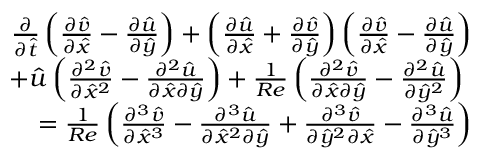<formula> <loc_0><loc_0><loc_500><loc_500>\begin{array} { r } { \frac { \partial } { \partial \hat { t } } \left ( { \frac { \partial \hat { v } } { \partial \hat { x } } - \frac { \partial \hat { u } } { \partial \hat { y } } } \right ) + \left ( { \frac { \partial \hat { u } } { \partial \hat { x } } + \frac { \partial \hat { v } } { \partial \hat { y } } } \right ) \left ( { \frac { \partial \hat { v } } { \partial \hat { x } } - \frac { \partial \hat { u } } { \partial \hat { y } } } \right ) } \\ { + \hat { u } \left ( { \frac { \partial ^ { 2 } \hat { v } } { \partial { \hat { x } } ^ { 2 } } - \frac { \partial ^ { 2 } \hat { u } } { \partial \hat { x } \partial \hat { y } } } \right ) + \frac { 1 } { R e } \left ( { \frac { \partial ^ { 2 } \hat { v } } { \partial \hat { x } \partial \hat { y } } - \frac { \partial ^ { 2 } \hat { u } } { \partial { \hat { y } } ^ { 2 } } } \right ) } \\ { = \frac { 1 } { R e } \left ( { \frac { \partial ^ { 3 } \hat { v } } { \partial { \hat { x } } ^ { 3 } } - \frac { \partial ^ { 3 } \hat { u } } { \partial { \hat { x } } ^ { 2 } \partial \hat { y } } + \frac { \partial ^ { 3 } \hat { v } } { \partial { \hat { y } } ^ { 2 } \partial \hat { x } } - \frac { \partial ^ { 3 } \hat { u } } { \partial { \hat { y } } ^ { 3 } } } \right ) } \end{array}</formula> 